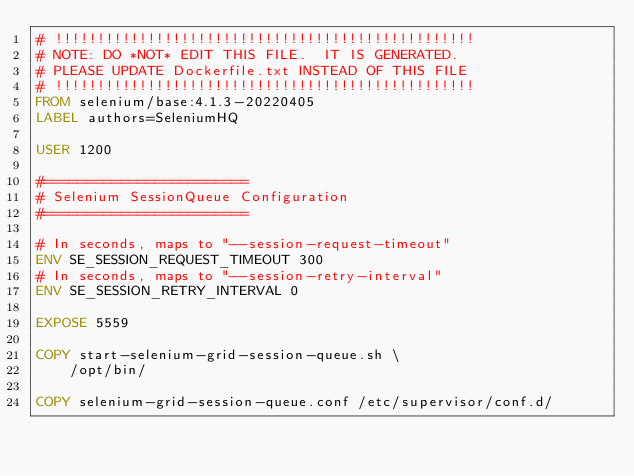<code> <loc_0><loc_0><loc_500><loc_500><_Dockerfile_># !!!!!!!!!!!!!!!!!!!!!!!!!!!!!!!!!!!!!!!!!!!!!!!!!!
# NOTE: DO *NOT* EDIT THIS FILE.  IT IS GENERATED.
# PLEASE UPDATE Dockerfile.txt INSTEAD OF THIS FILE
# !!!!!!!!!!!!!!!!!!!!!!!!!!!!!!!!!!!!!!!!!!!!!!!!!!
FROM selenium/base:4.1.3-20220405
LABEL authors=SeleniumHQ

USER 1200

#========================
# Selenium SessionQueue Configuration
#========================

# In seconds, maps to "--session-request-timeout"
ENV SE_SESSION_REQUEST_TIMEOUT 300
# In seconds, maps to "--session-retry-interval"
ENV SE_SESSION_RETRY_INTERVAL 0

EXPOSE 5559

COPY start-selenium-grid-session-queue.sh \
    /opt/bin/

COPY selenium-grid-session-queue.conf /etc/supervisor/conf.d/
</code> 